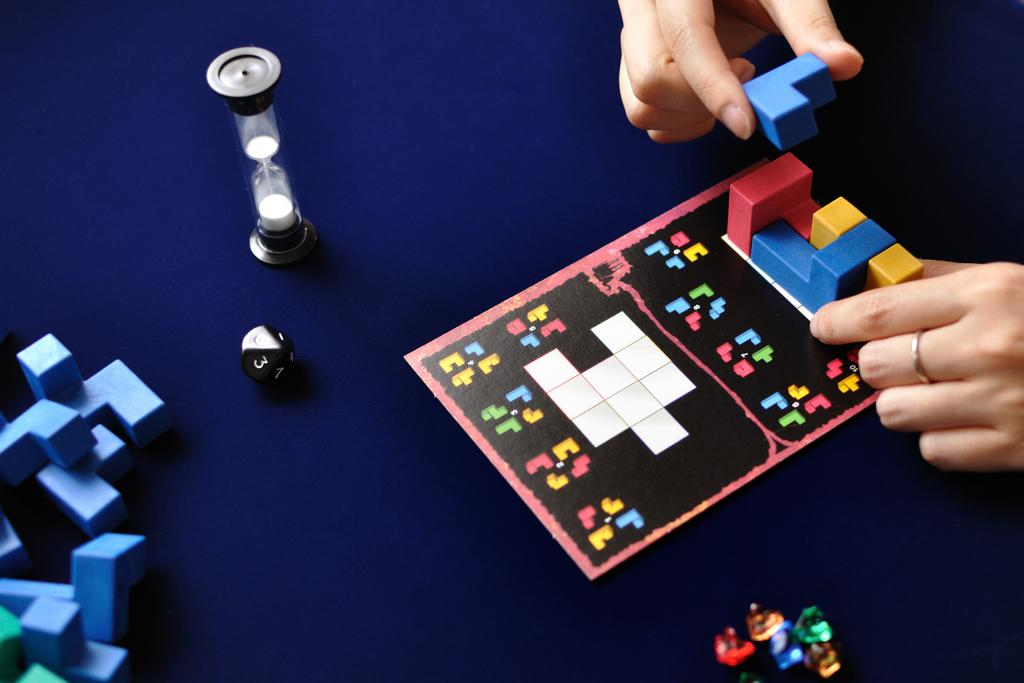What type of objects are present in the image? There are building blocks, a board, and toys in the image. What is the color of the surface in the image? The surface is blue. What activity might be taking place in the image? Human hands are holding building blocks on the right side of the image, suggesting that building or stacking blocks is happening. What type of doctor can be seen treating a donkey in the park in the image? There is no doctor, donkey, or park present in the image. 